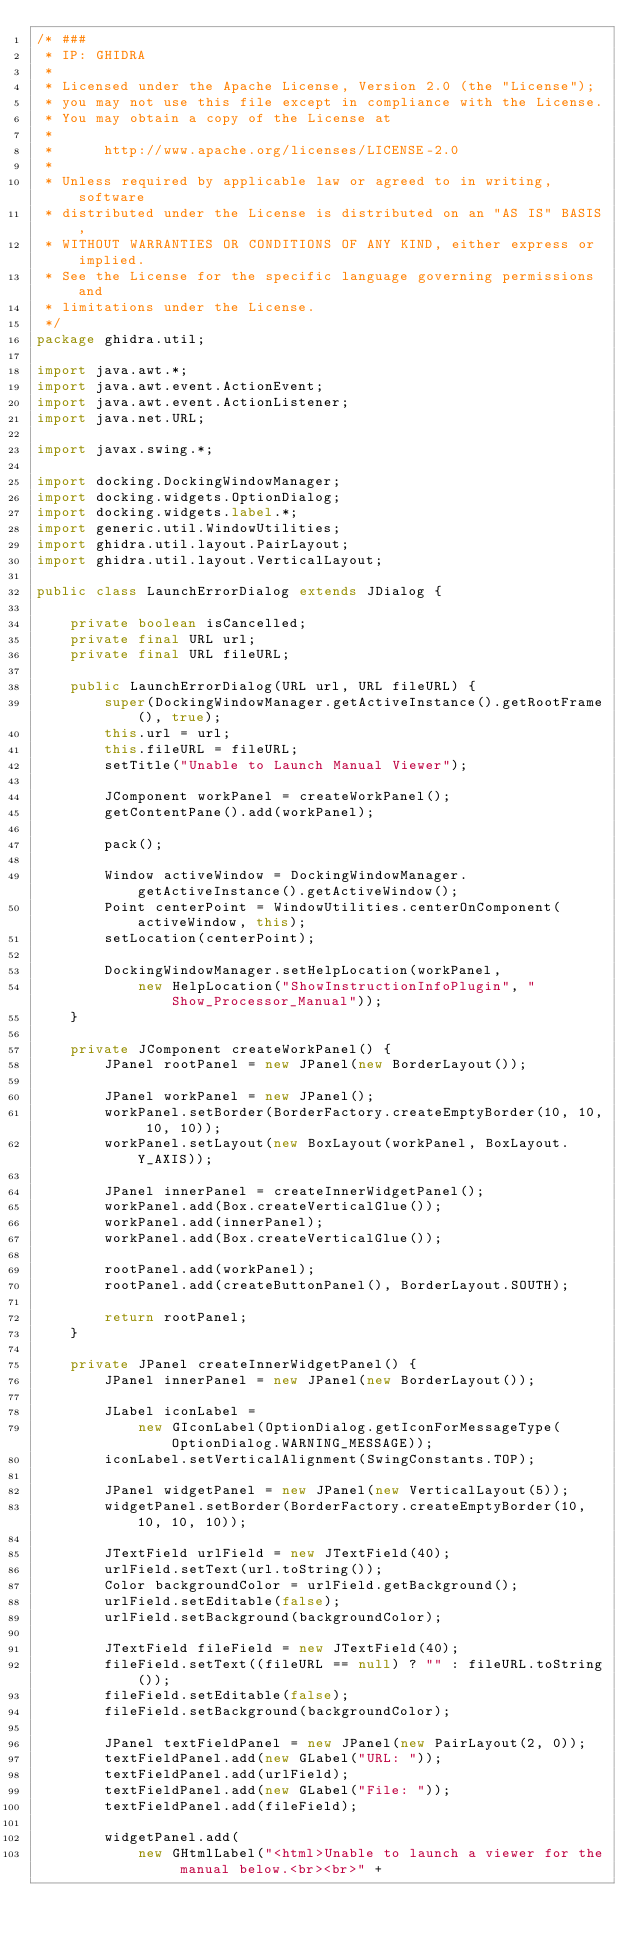<code> <loc_0><loc_0><loc_500><loc_500><_Java_>/* ###
 * IP: GHIDRA
 *
 * Licensed under the Apache License, Version 2.0 (the "License");
 * you may not use this file except in compliance with the License.
 * You may obtain a copy of the License at
 * 
 *      http://www.apache.org/licenses/LICENSE-2.0
 * 
 * Unless required by applicable law or agreed to in writing, software
 * distributed under the License is distributed on an "AS IS" BASIS,
 * WITHOUT WARRANTIES OR CONDITIONS OF ANY KIND, either express or implied.
 * See the License for the specific language governing permissions and
 * limitations under the License.
 */
package ghidra.util;

import java.awt.*;
import java.awt.event.ActionEvent;
import java.awt.event.ActionListener;
import java.net.URL;

import javax.swing.*;

import docking.DockingWindowManager;
import docking.widgets.OptionDialog;
import docking.widgets.label.*;
import generic.util.WindowUtilities;
import ghidra.util.layout.PairLayout;
import ghidra.util.layout.VerticalLayout;

public class LaunchErrorDialog extends JDialog {

	private boolean isCancelled;
	private final URL url;
	private final URL fileURL;

	public LaunchErrorDialog(URL url, URL fileURL) {
		super(DockingWindowManager.getActiveInstance().getRootFrame(), true);
		this.url = url;
		this.fileURL = fileURL;
		setTitle("Unable to Launch Manual Viewer");

		JComponent workPanel = createWorkPanel();
		getContentPane().add(workPanel);

		pack();

		Window activeWindow = DockingWindowManager.getActiveInstance().getActiveWindow();
		Point centerPoint = WindowUtilities.centerOnComponent(activeWindow, this);
		setLocation(centerPoint);

		DockingWindowManager.setHelpLocation(workPanel,
			new HelpLocation("ShowInstructionInfoPlugin", "Show_Processor_Manual"));
	}

	private JComponent createWorkPanel() {
		JPanel rootPanel = new JPanel(new BorderLayout());

		JPanel workPanel = new JPanel();
		workPanel.setBorder(BorderFactory.createEmptyBorder(10, 10, 10, 10));
		workPanel.setLayout(new BoxLayout(workPanel, BoxLayout.Y_AXIS));

		JPanel innerPanel = createInnerWidgetPanel();
		workPanel.add(Box.createVerticalGlue());
		workPanel.add(innerPanel);
		workPanel.add(Box.createVerticalGlue());

		rootPanel.add(workPanel);
		rootPanel.add(createButtonPanel(), BorderLayout.SOUTH);

		return rootPanel;
	}

	private JPanel createInnerWidgetPanel() {
		JPanel innerPanel = new JPanel(new BorderLayout());

		JLabel iconLabel =
			new GIconLabel(OptionDialog.getIconForMessageType(OptionDialog.WARNING_MESSAGE));
		iconLabel.setVerticalAlignment(SwingConstants.TOP);

		JPanel widgetPanel = new JPanel(new VerticalLayout(5));
		widgetPanel.setBorder(BorderFactory.createEmptyBorder(10, 10, 10, 10));

		JTextField urlField = new JTextField(40);
		urlField.setText(url.toString());
		Color backgroundColor = urlField.getBackground();
		urlField.setEditable(false);
		urlField.setBackground(backgroundColor);

		JTextField fileField = new JTextField(40);
		fileField.setText((fileURL == null) ? "" : fileURL.toString());
		fileField.setEditable(false);
		fileField.setBackground(backgroundColor);

		JPanel textFieldPanel = new JPanel(new PairLayout(2, 0));
		textFieldPanel.add(new GLabel("URL: "));
		textFieldPanel.add(urlField);
		textFieldPanel.add(new GLabel("File: "));
		textFieldPanel.add(fileField);

		widgetPanel.add(
			new GHtmlLabel("<html>Unable to launch a viewer for the manual below.<br><br>" +</code> 